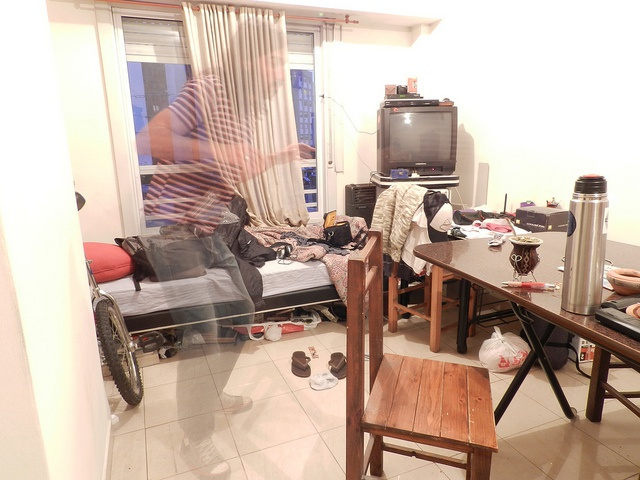Describe the objects in this image and their specific colors. I can see people in white, tan, darkgray, and gray tones, chair in white, salmon, maroon, and brown tones, dining table in white, tan, gray, and maroon tones, tv in white, darkgray, and gray tones, and chair in white, maroon, black, red, and brown tones in this image. 